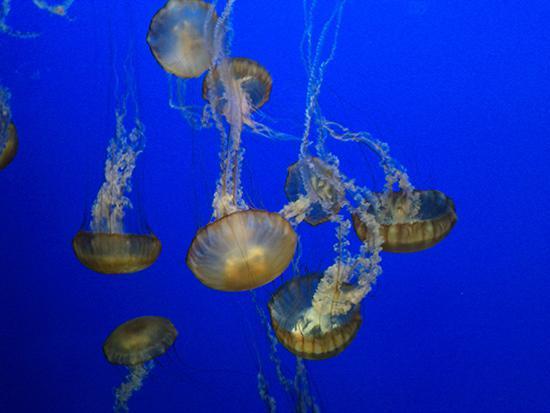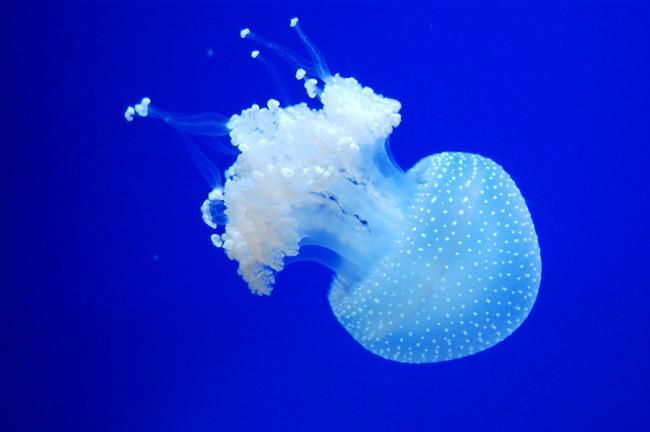The first image is the image on the left, the second image is the image on the right. For the images displayed, is the sentence "Foreground of the right image shows exactly two polka-dotted mushroom-shaped jellyfish with frilly tendrils." factually correct? Answer yes or no. No. The first image is the image on the left, the second image is the image on the right. Examine the images to the left and right. Is the description "Some jellyfish are traveling downwards." accurate? Answer yes or no. Yes. 